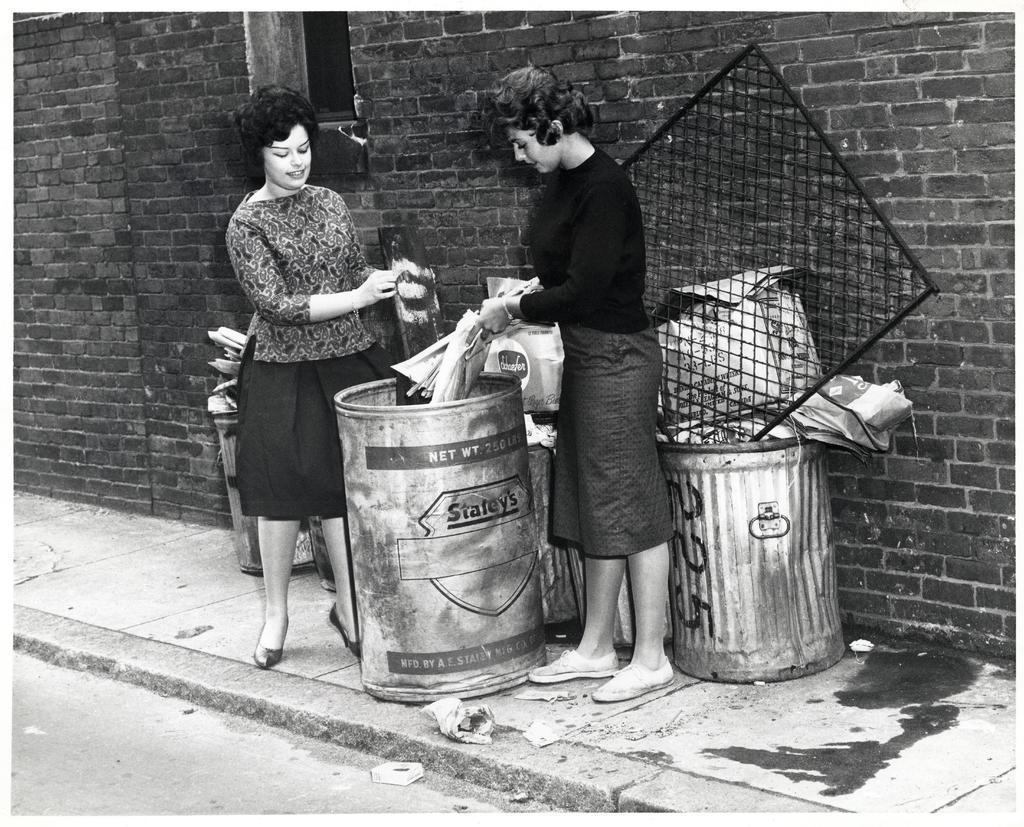<image>
Summarize the visual content of the image. Two ladies are dumping things in a Staley's trash can. 